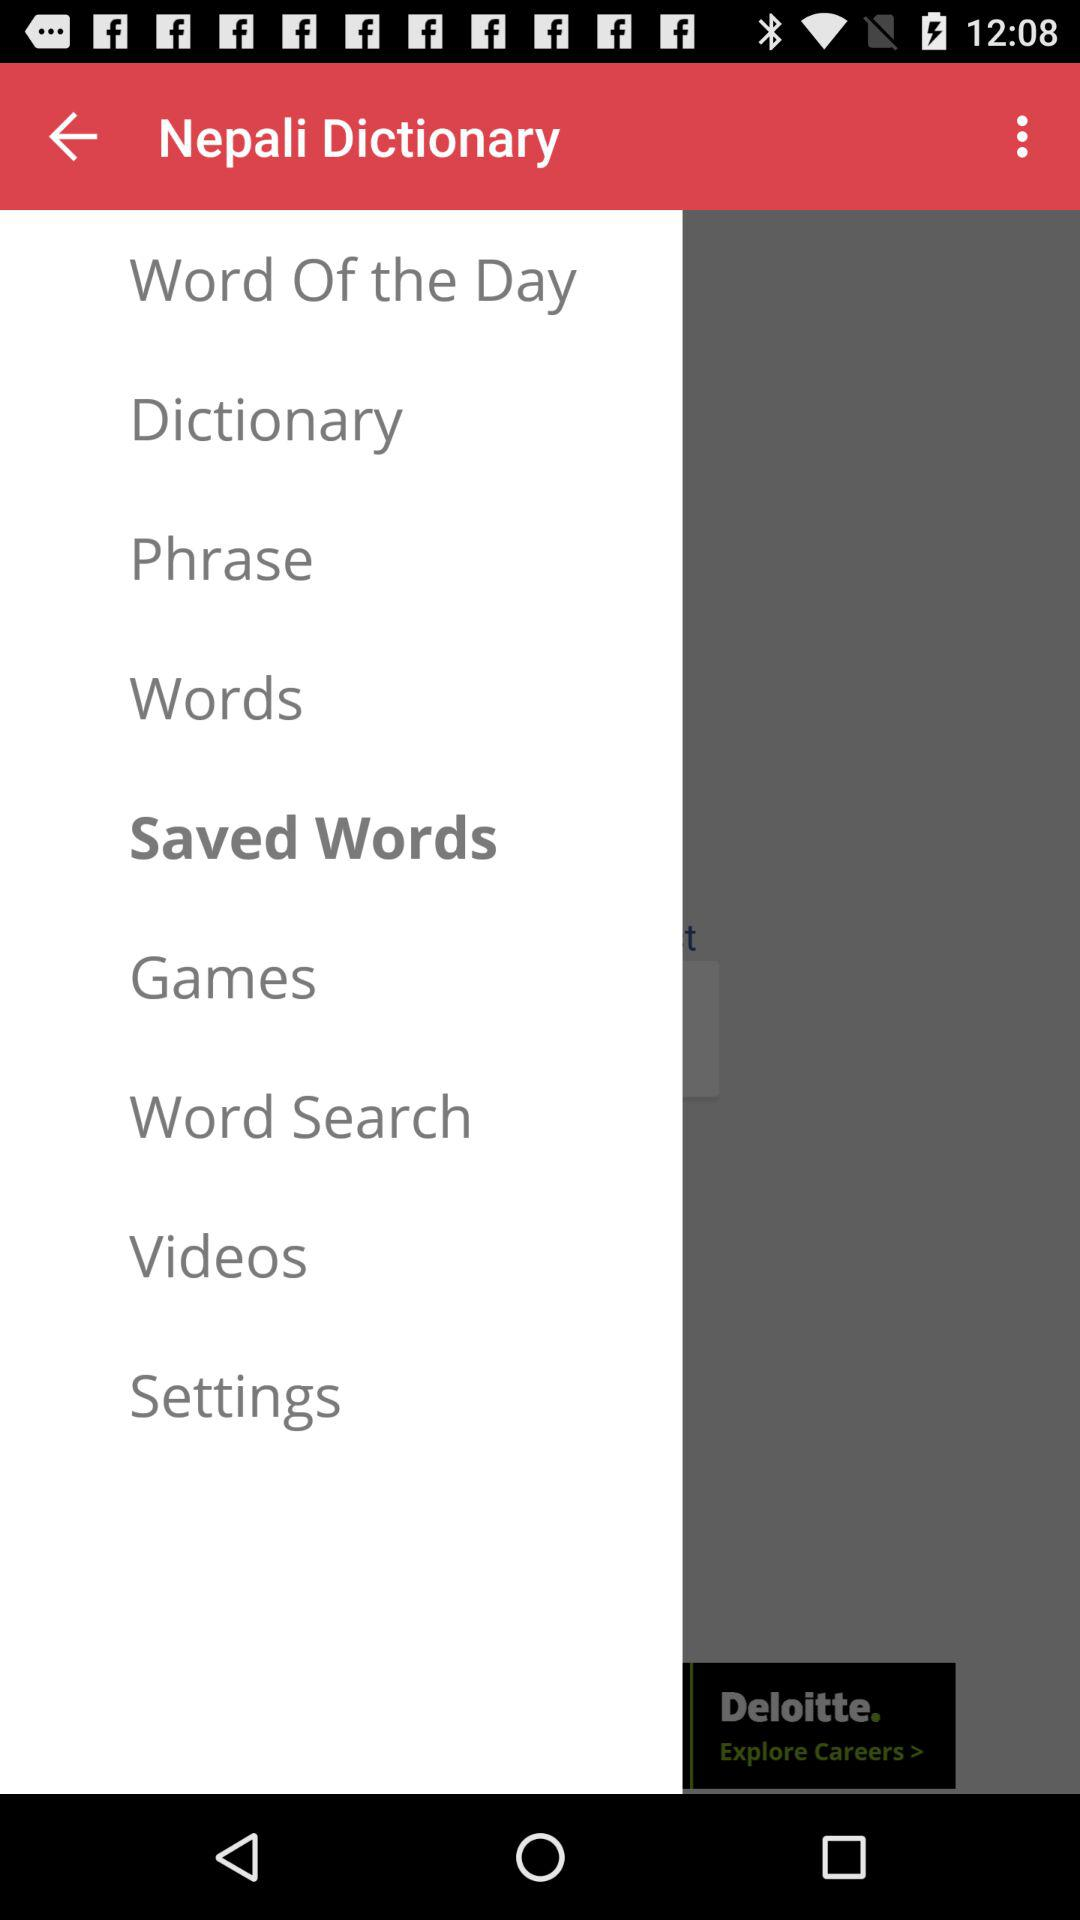What is the word of the day?
When the provided information is insufficient, respond with <no answer>. <no answer> 